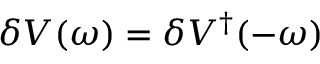<formula> <loc_0><loc_0><loc_500><loc_500>\delta V ( \omega ) = \delta V ^ { \dagger } ( - \omega )</formula> 